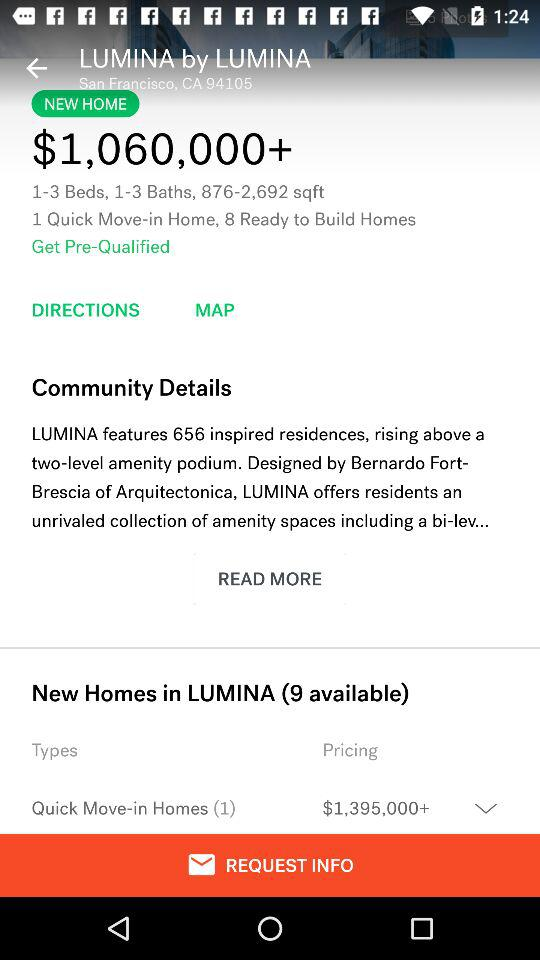What is the area? The area ranges from 876 square feet to 2,692 square feet. 